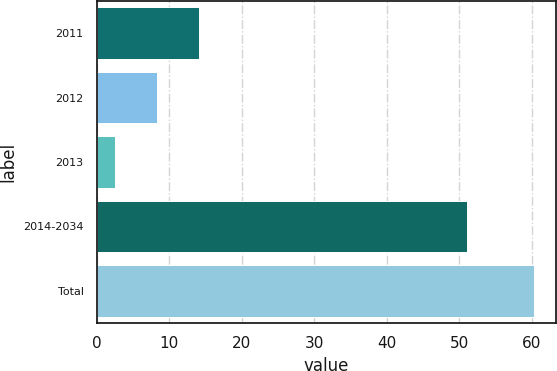Convert chart. <chart><loc_0><loc_0><loc_500><loc_500><bar_chart><fcel>2011<fcel>2012<fcel>2013<fcel>2014-2034<fcel>Total<nl><fcel>14.08<fcel>8.29<fcel>2.5<fcel>51.1<fcel>60.4<nl></chart> 